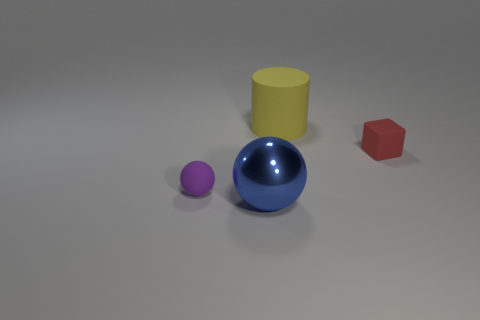Add 2 big shiny cylinders. How many objects exist? 6 Subtract all cylinders. How many objects are left? 3 Subtract all green rubber blocks. Subtract all large blue spheres. How many objects are left? 3 Add 4 small purple balls. How many small purple balls are left? 5 Add 3 big metallic objects. How many big metallic objects exist? 4 Subtract 1 purple spheres. How many objects are left? 3 